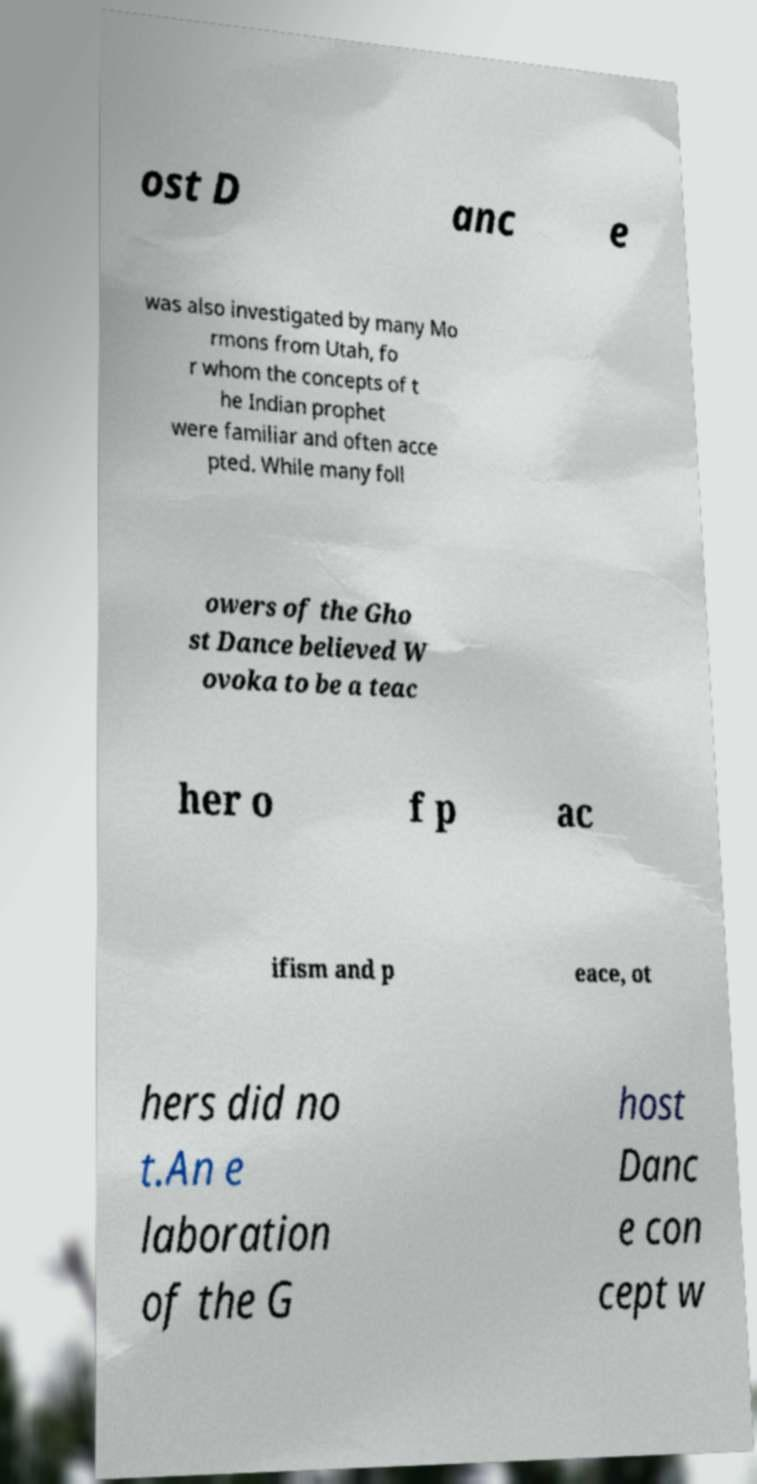I need the written content from this picture converted into text. Can you do that? ost D anc e was also investigated by many Mo rmons from Utah, fo r whom the concepts of t he Indian prophet were familiar and often acce pted. While many foll owers of the Gho st Dance believed W ovoka to be a teac her o f p ac ifism and p eace, ot hers did no t.An e laboration of the G host Danc e con cept w 